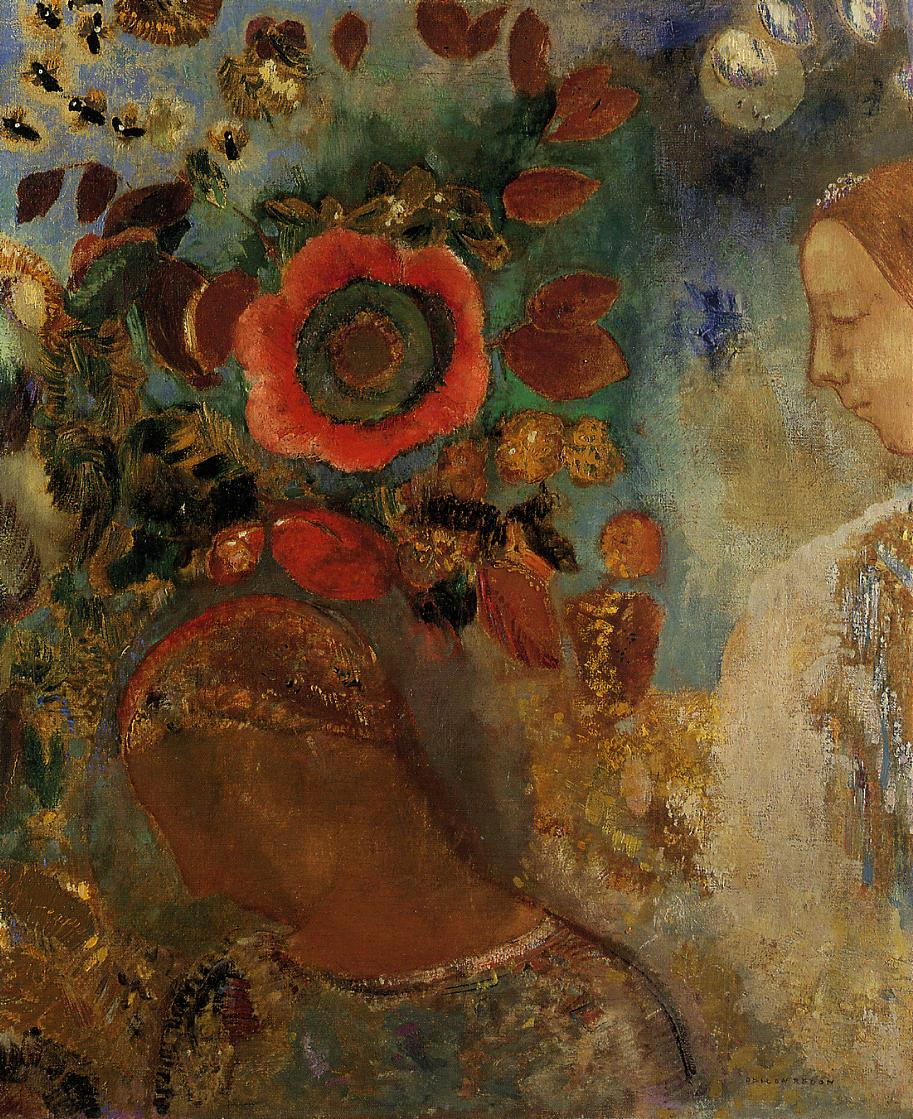What does the large red flower symbolize in this painting? The large red flower prominently positioned near the woman might symbolize vibrancy, passion, or a bursting vitality. Given the overall soothing atmosphere of the painting, it could also represent a source of emotional strength or a beacon of personal significance in the subject's life. Flowers often carry symbolic weight in art, and here, the red flower's bold presence amid softer surroundings might highlight a focal point of personal or spiritual importance. 